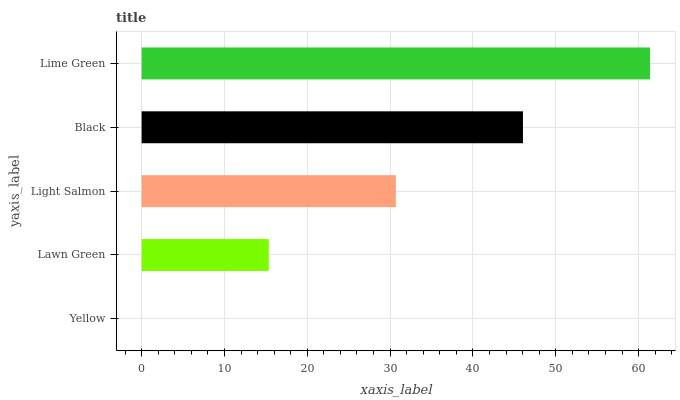Is Yellow the minimum?
Answer yes or no. Yes. Is Lime Green the maximum?
Answer yes or no. Yes. Is Lawn Green the minimum?
Answer yes or no. No. Is Lawn Green the maximum?
Answer yes or no. No. Is Lawn Green greater than Yellow?
Answer yes or no. Yes. Is Yellow less than Lawn Green?
Answer yes or no. Yes. Is Yellow greater than Lawn Green?
Answer yes or no. No. Is Lawn Green less than Yellow?
Answer yes or no. No. Is Light Salmon the high median?
Answer yes or no. Yes. Is Light Salmon the low median?
Answer yes or no. Yes. Is Yellow the high median?
Answer yes or no. No. Is Yellow the low median?
Answer yes or no. No. 